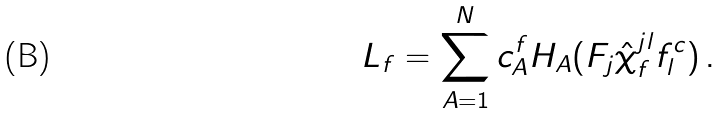Convert formula to latex. <formula><loc_0><loc_0><loc_500><loc_500>L _ { f } = \sum ^ { N } _ { A = 1 } c ^ { f } _ { A } H _ { A } ( F _ { j } \hat { \chi } _ { f } ^ { j l } f ^ { c } _ { l } ) \, .</formula> 